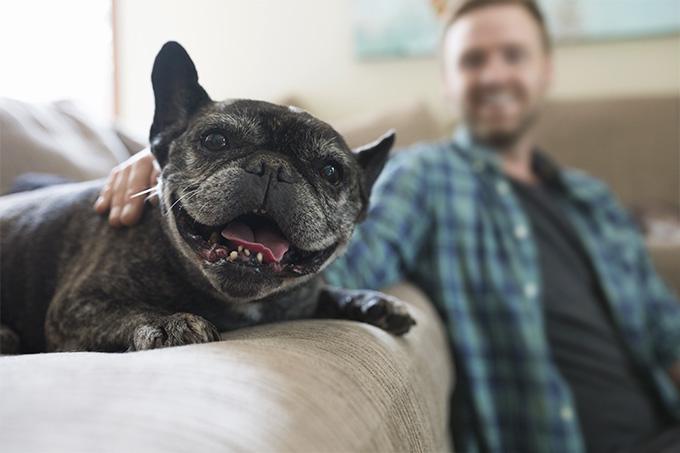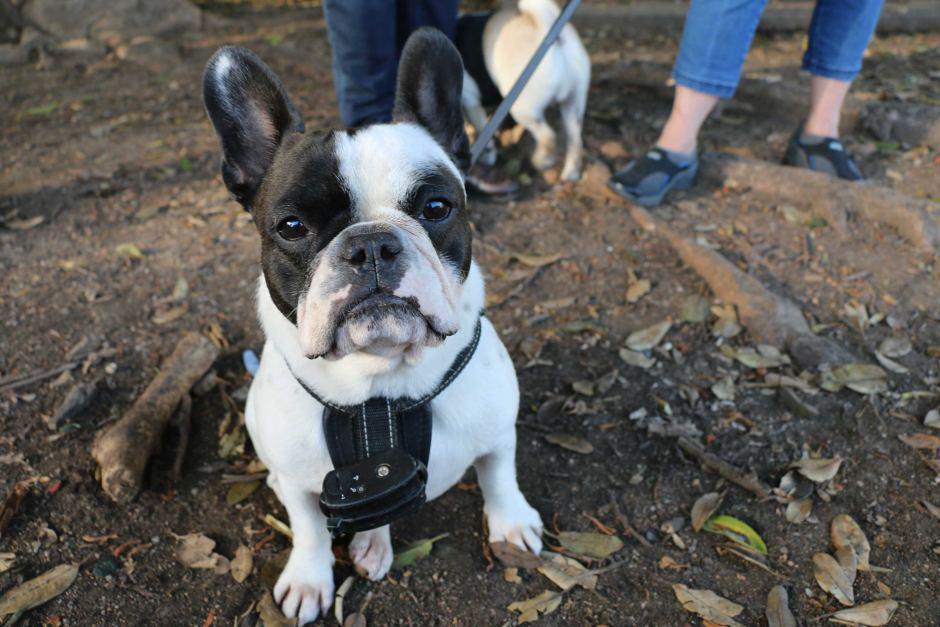The first image is the image on the left, the second image is the image on the right. Given the left and right images, does the statement "One image features exactly two dogs posed close together and facing  forward." hold true? Answer yes or no. No. 